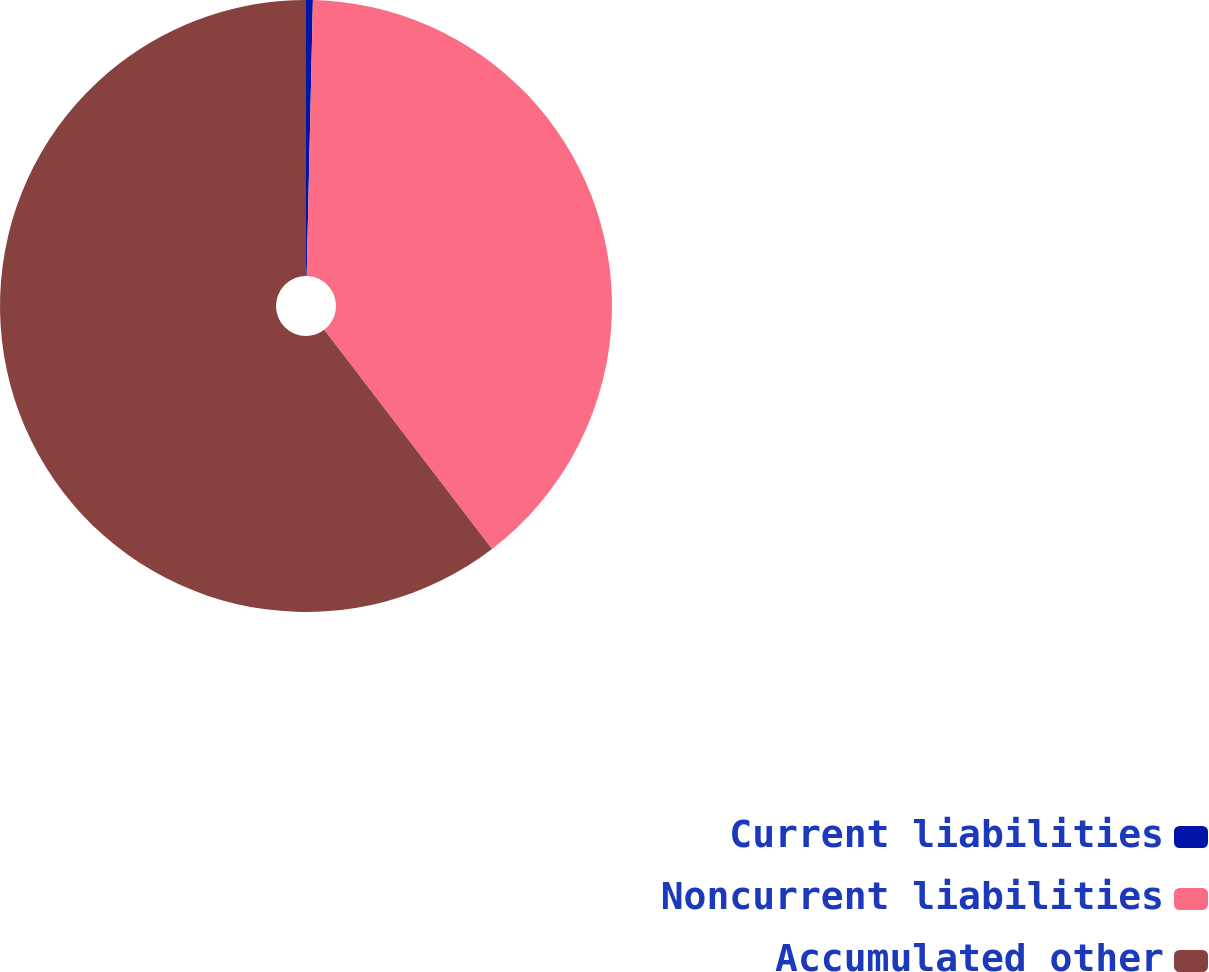Convert chart to OTSL. <chart><loc_0><loc_0><loc_500><loc_500><pie_chart><fcel>Current liabilities<fcel>Noncurrent liabilities<fcel>Accumulated other<nl><fcel>0.36%<fcel>39.24%<fcel>60.4%<nl></chart> 